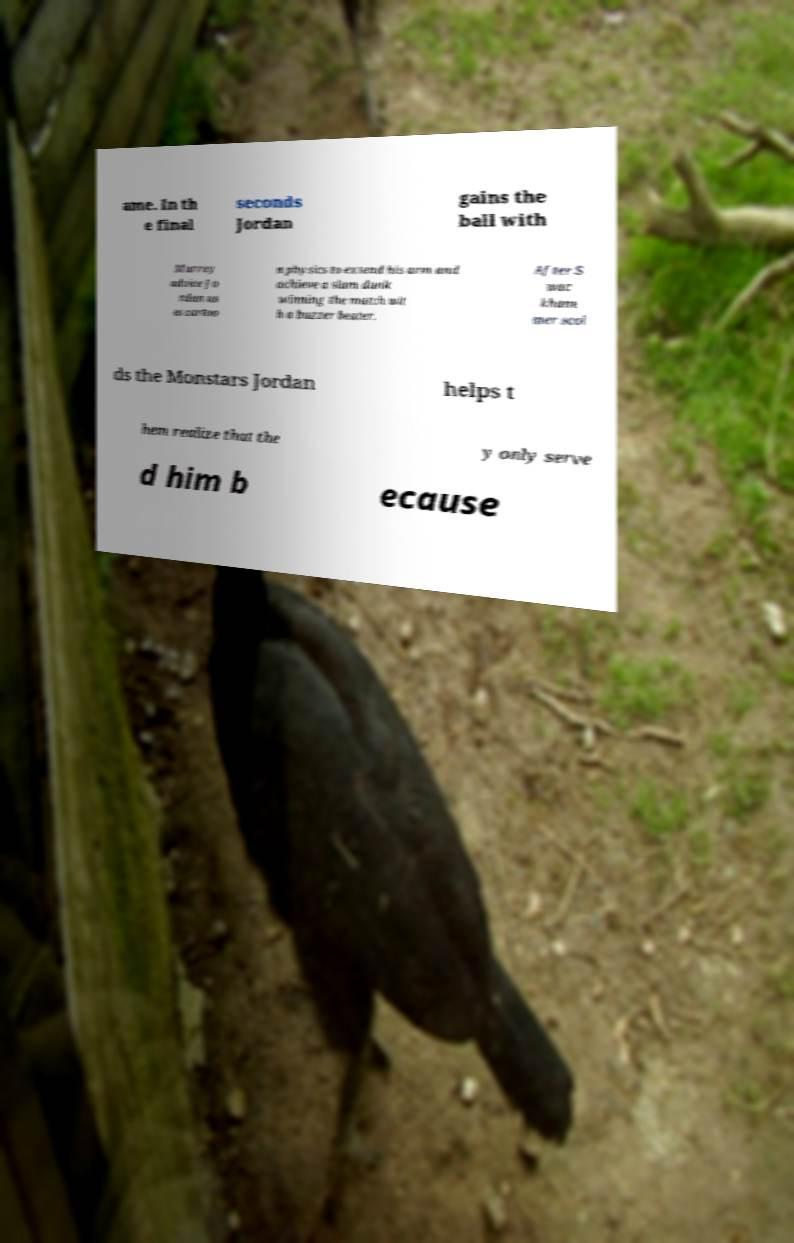Could you extract and type out the text from this image? ame. In th e final seconds Jordan gains the ball with Murray advice Jo rdan us es cartoo n physics to extend his arm and achieve a slam dunk winning the match wit h a buzzer beater. After S wac kham mer scol ds the Monstars Jordan helps t hem realize that the y only serve d him b ecause 